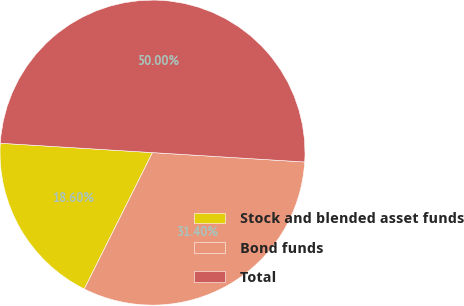Convert chart to OTSL. <chart><loc_0><loc_0><loc_500><loc_500><pie_chart><fcel>Stock and blended asset funds<fcel>Bond funds<fcel>Total<nl><fcel>18.6%<fcel>31.4%<fcel>50.0%<nl></chart> 